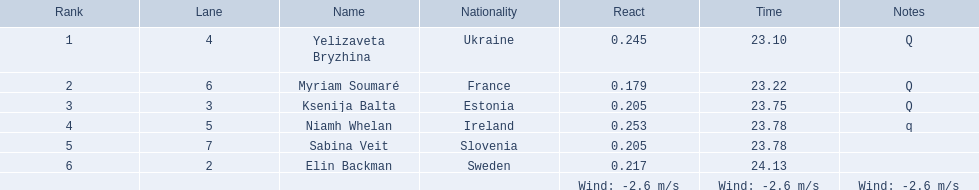What place did elin backman finish the race in? 6. How long did it take him to finish? 24.13. 